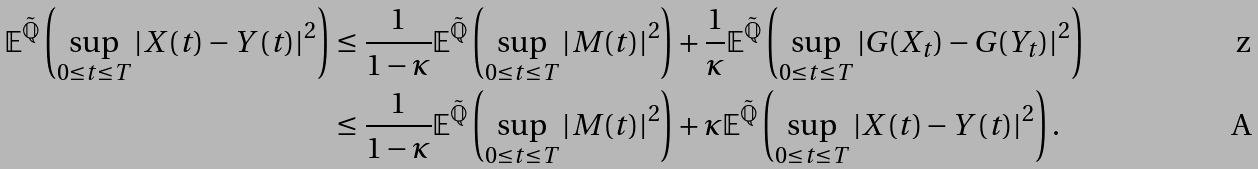Convert formula to latex. <formula><loc_0><loc_0><loc_500><loc_500>\mathbb { E } ^ { \tilde { \mathbb { Q } } } \left ( \sup _ { 0 \leq t \leq T } | X ( t ) - Y ( t ) | ^ { 2 } \right ) & \leq \frac { 1 } { 1 - \kappa } \mathbb { E } ^ { \tilde { \mathbb { Q } } } \left ( \sup _ { 0 \leq t \leq T } | M ( t ) | ^ { 2 } \right ) + \frac { 1 } { \kappa } \mathbb { E } ^ { \tilde { \mathbb { Q } } } \left ( \sup _ { 0 \leq t \leq T } | G ( X _ { t } ) - G ( Y _ { t } ) | ^ { 2 } \right ) \\ & \leq \frac { 1 } { 1 - \kappa } \mathbb { E } ^ { \tilde { \mathbb { Q } } } \left ( \sup _ { 0 \leq t \leq T } | M ( t ) | ^ { 2 } \right ) + \kappa \mathbb { E } ^ { \tilde { \mathbb { Q } } } \left ( \sup _ { 0 \leq t \leq T } | X ( t ) - Y ( t ) | ^ { 2 } \right ) .</formula> 